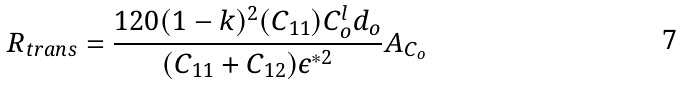Convert formula to latex. <formula><loc_0><loc_0><loc_500><loc_500>R _ { t r a n s } = \frac { 1 2 0 ( 1 - k ) ^ { 2 } ( C _ { 1 1 } ) C _ { o } ^ { l } d _ { o } } { ( C _ { 1 1 } + C _ { 1 2 } ) \epsilon ^ { * 2 } } A _ { C _ { o } }</formula> 